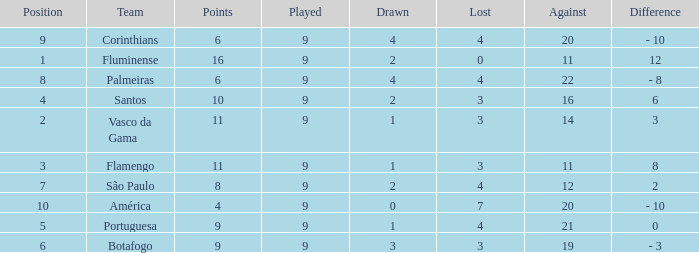Which Position has a Played larger than 9? None. 